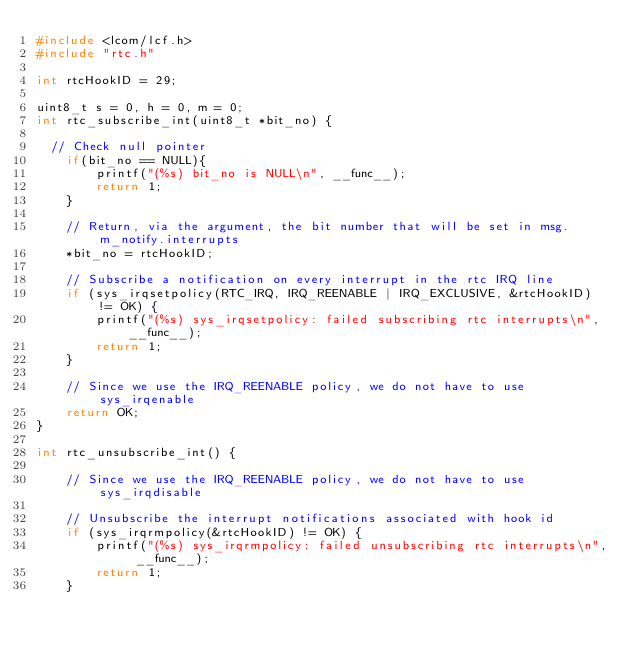Convert code to text. <code><loc_0><loc_0><loc_500><loc_500><_C_>#include <lcom/lcf.h>
#include "rtc.h"

int rtcHookID = 29;

uint8_t s = 0, h = 0, m = 0;
int rtc_subscribe_int(uint8_t *bit_no) {

	// Check null pointer
    if(bit_no == NULL){
        printf("(%s) bit_no is NULL\n", __func__);
        return 1;
    }

    // Return, via the argument, the bit number that will be set in msg.m_notify.interrupts
    *bit_no = rtcHookID;

    // Subscribe a notification on every interrupt in the rtc IRQ line
    if (sys_irqsetpolicy(RTC_IRQ, IRQ_REENABLE | IRQ_EXCLUSIVE, &rtcHookID) != OK) {
        printf("(%s) sys_irqsetpolicy: failed subscribing rtc interrupts\n", __func__);
        return 1;
    }

    // Since we use the IRQ_REENABLE policy, we do not have to use sys_irqenable
    return OK;
}

int rtc_unsubscribe_int() {
    
    // Since we use the IRQ_REENABLE policy, we do not have to use sys_irqdisable

    // Unsubscribe the interrupt notifications associated with hook id
    if (sys_irqrmpolicy(&rtcHookID) != OK) {
        printf("(%s) sys_irqrmpolicy: failed unsubscribing rtc interrupts\n", __func__);
        return 1;
    }
</code> 